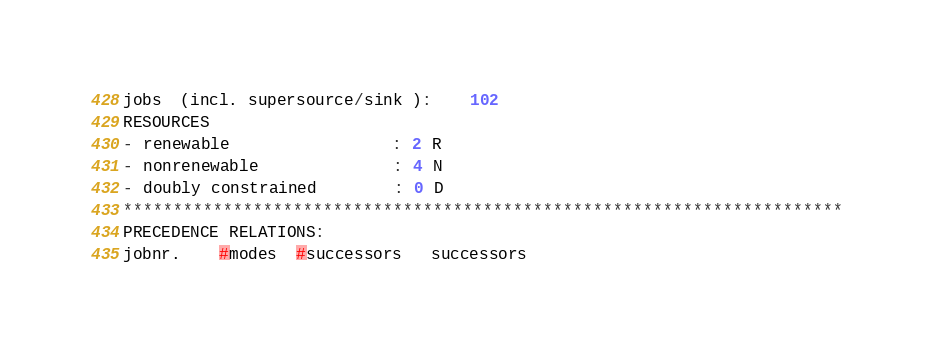Convert code to text. <code><loc_0><loc_0><loc_500><loc_500><_ObjectiveC_>jobs  (incl. supersource/sink ):	102
RESOURCES
- renewable                 : 2 R
- nonrenewable              : 4 N
- doubly constrained        : 0 D
************************************************************************
PRECEDENCE RELATIONS:
jobnr.    #modes  #successors   successors</code> 